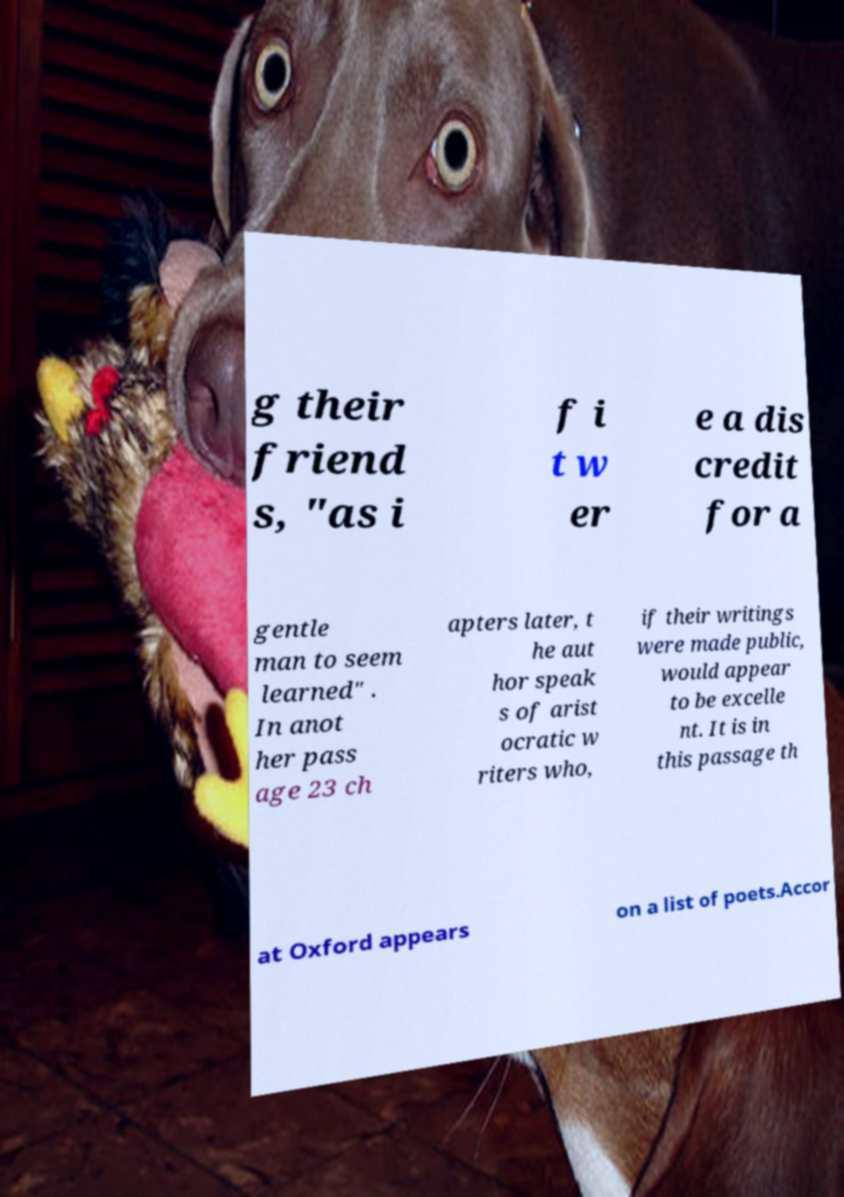Please identify and transcribe the text found in this image. g their friend s, "as i f i t w er e a dis credit for a gentle man to seem learned" . In anot her pass age 23 ch apters later, t he aut hor speak s of arist ocratic w riters who, if their writings were made public, would appear to be excelle nt. It is in this passage th at Oxford appears on a list of poets.Accor 